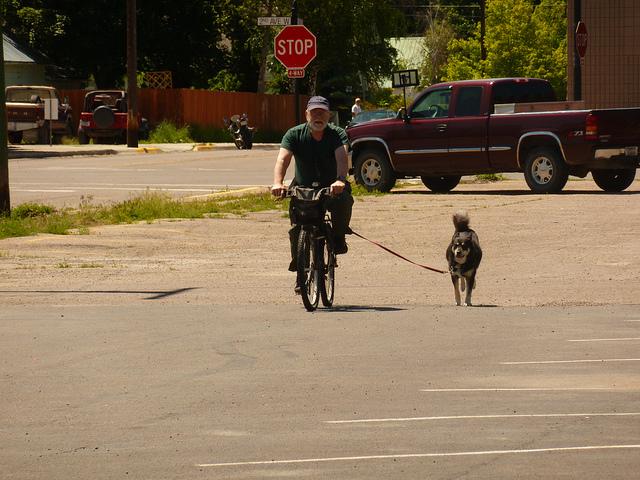How many people are visible in the picture?
Concise answer only. 1. Where is the man riding his bike?
Answer briefly. Parking lot. Is that a fire truck in the street?
Answer briefly. No. Is the dog in the air?
Short answer required. No. How many dogs is the man walking?
Quick response, please. 1. What is the guy riding?
Answer briefly. Bike. Is the dog running?
Quick response, please. Yes. What kind of dogs is the man walking?
Short answer required. Husky. What color is the truck?
Quick response, please. Red. Is it dark out?
Keep it brief. No. 